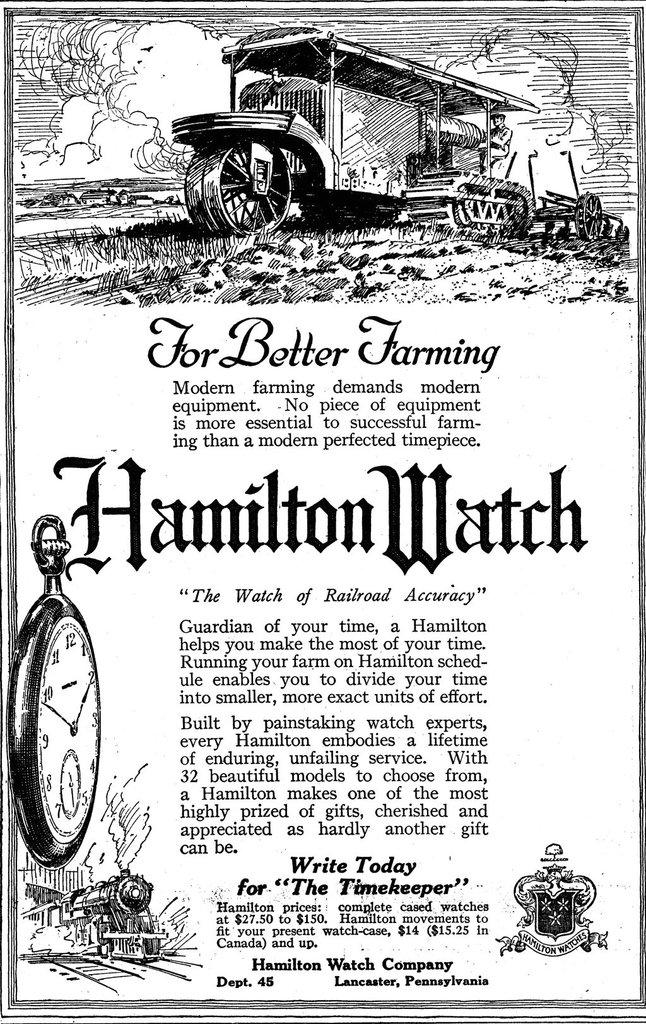<image>
Summarize the visual content of the image. An old advertisement of Hamilton watch claims the watch is for better farming. 